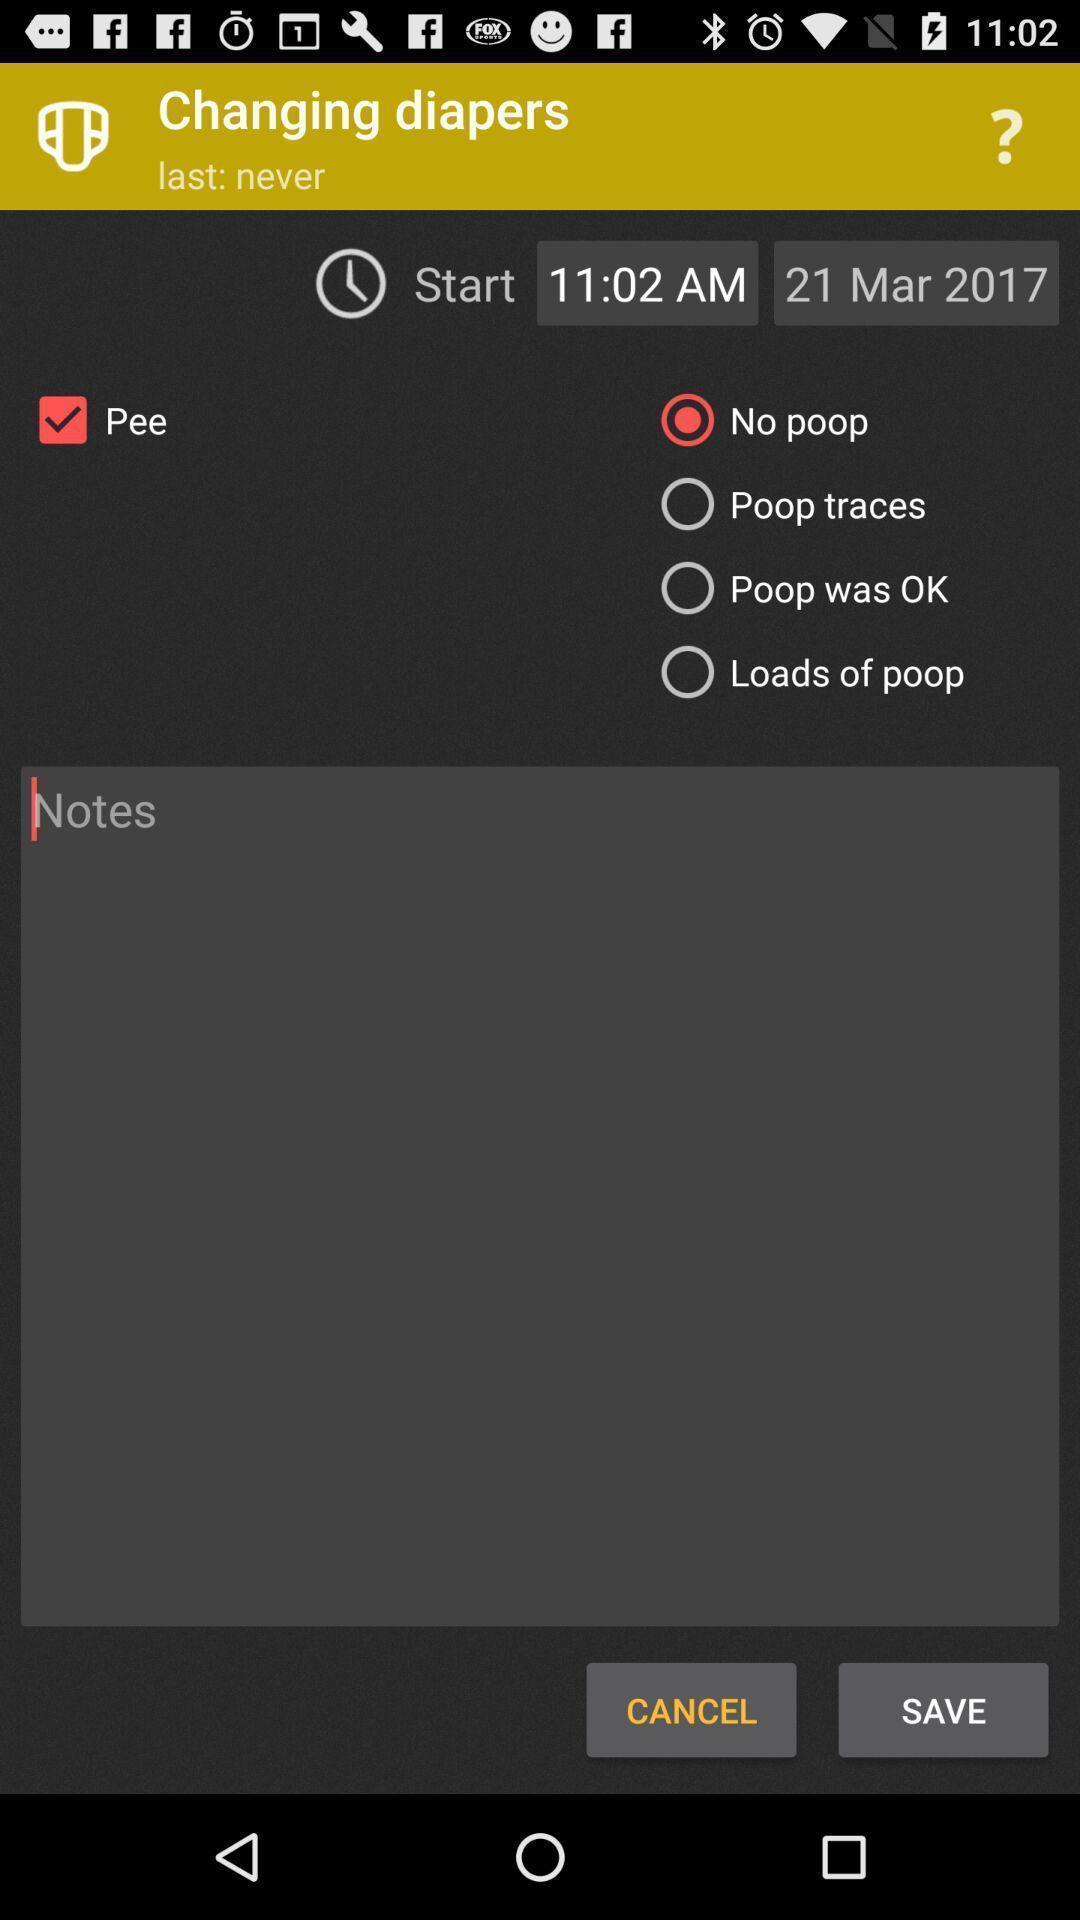What can you discern from this picture? Page displaying various options about diapers in a baby app. 